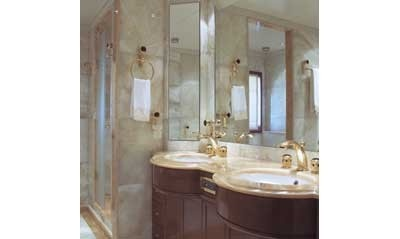Describe the objects in this image and their specific colors. I can see a sink in white, lightgray, and tan tones in this image. 